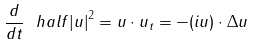<formula> <loc_0><loc_0><loc_500><loc_500>\frac { d } { d t } \ h a l f { { | u | } ^ { 2 } } = u \cdot { u _ { t } } = - ( i u ) \cdot \Delta u</formula> 